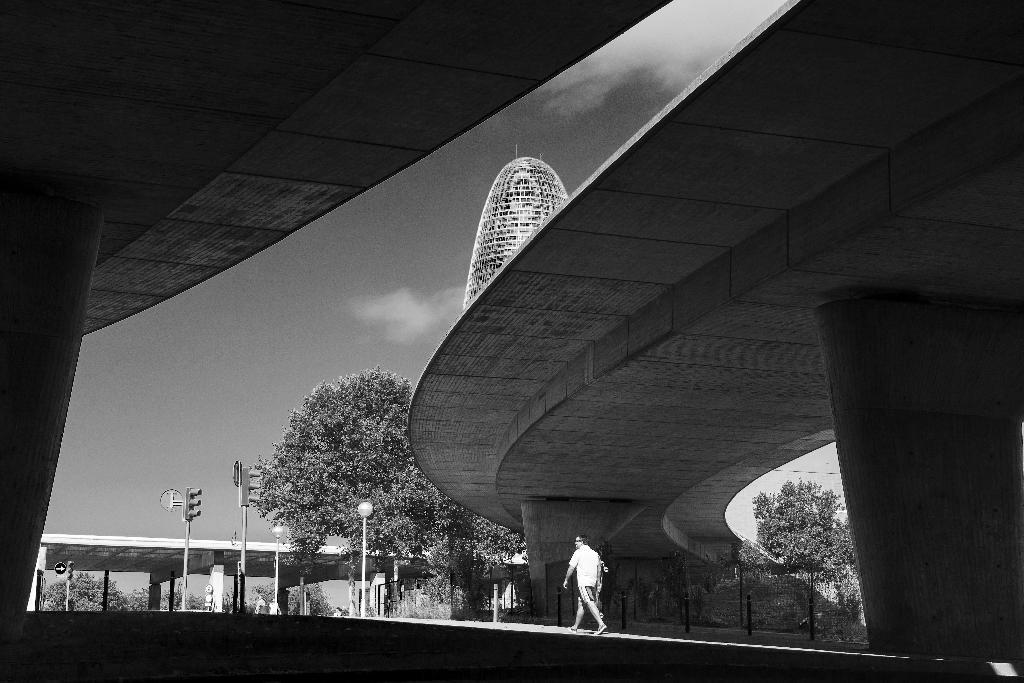How many people are present in the image? There are two men in the image. What structures can be seen in the image? There are bridges, poles, traffic lights, and a tower in the image. What type of vegetation is visible in the image? There are trees in the image. What color is the cabbage that is being used as a wheel in the image? There is no cabbage or wheel present in the image. How many eyes can be seen on the tower in the image? The tower in the image does not have any eyes; it is a structure without facial features. 